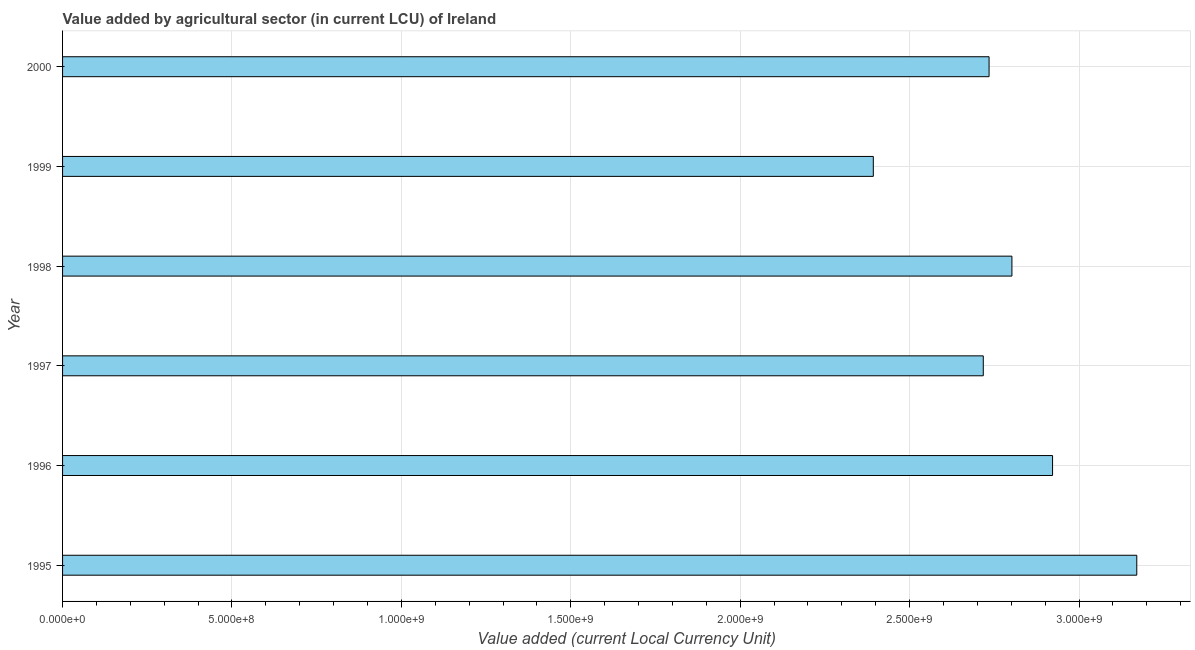Does the graph contain grids?
Make the answer very short. Yes. What is the title of the graph?
Your answer should be very brief. Value added by agricultural sector (in current LCU) of Ireland. What is the label or title of the X-axis?
Provide a succinct answer. Value added (current Local Currency Unit). What is the value added by agriculture sector in 1997?
Provide a succinct answer. 2.72e+09. Across all years, what is the maximum value added by agriculture sector?
Offer a very short reply. 3.17e+09. Across all years, what is the minimum value added by agriculture sector?
Keep it short and to the point. 2.39e+09. What is the sum of the value added by agriculture sector?
Offer a terse response. 1.67e+1. What is the difference between the value added by agriculture sector in 1997 and 2000?
Ensure brevity in your answer.  -1.71e+07. What is the average value added by agriculture sector per year?
Your response must be concise. 2.79e+09. What is the median value added by agriculture sector?
Provide a short and direct response. 2.77e+09. What is the ratio of the value added by agriculture sector in 1995 to that in 1998?
Provide a succinct answer. 1.13. Is the difference between the value added by agriculture sector in 1995 and 1999 greater than the difference between any two years?
Give a very brief answer. Yes. What is the difference between the highest and the second highest value added by agriculture sector?
Give a very brief answer. 2.49e+08. Is the sum of the value added by agriculture sector in 1997 and 1999 greater than the maximum value added by agriculture sector across all years?
Offer a very short reply. Yes. What is the difference between the highest and the lowest value added by agriculture sector?
Offer a very short reply. 7.78e+08. How many bars are there?
Offer a very short reply. 6. How many years are there in the graph?
Your answer should be very brief. 6. What is the difference between two consecutive major ticks on the X-axis?
Give a very brief answer. 5.00e+08. Are the values on the major ticks of X-axis written in scientific E-notation?
Keep it short and to the point. Yes. What is the Value added (current Local Currency Unit) of 1995?
Your answer should be very brief. 3.17e+09. What is the Value added (current Local Currency Unit) of 1996?
Offer a terse response. 2.92e+09. What is the Value added (current Local Currency Unit) of 1997?
Your response must be concise. 2.72e+09. What is the Value added (current Local Currency Unit) of 1998?
Offer a very short reply. 2.80e+09. What is the Value added (current Local Currency Unit) in 1999?
Provide a succinct answer. 2.39e+09. What is the Value added (current Local Currency Unit) of 2000?
Offer a very short reply. 2.73e+09. What is the difference between the Value added (current Local Currency Unit) in 1995 and 1996?
Your answer should be compact. 2.49e+08. What is the difference between the Value added (current Local Currency Unit) in 1995 and 1997?
Ensure brevity in your answer.  4.53e+08. What is the difference between the Value added (current Local Currency Unit) in 1995 and 1998?
Give a very brief answer. 3.68e+08. What is the difference between the Value added (current Local Currency Unit) in 1995 and 1999?
Offer a very short reply. 7.78e+08. What is the difference between the Value added (current Local Currency Unit) in 1995 and 2000?
Ensure brevity in your answer.  4.36e+08. What is the difference between the Value added (current Local Currency Unit) in 1996 and 1997?
Offer a very short reply. 2.04e+08. What is the difference between the Value added (current Local Currency Unit) in 1996 and 1998?
Ensure brevity in your answer.  1.20e+08. What is the difference between the Value added (current Local Currency Unit) in 1996 and 1999?
Your answer should be compact. 5.29e+08. What is the difference between the Value added (current Local Currency Unit) in 1996 and 2000?
Provide a short and direct response. 1.87e+08. What is the difference between the Value added (current Local Currency Unit) in 1997 and 1998?
Ensure brevity in your answer.  -8.45e+07. What is the difference between the Value added (current Local Currency Unit) in 1997 and 1999?
Your response must be concise. 3.25e+08. What is the difference between the Value added (current Local Currency Unit) in 1997 and 2000?
Your response must be concise. -1.71e+07. What is the difference between the Value added (current Local Currency Unit) in 1998 and 1999?
Offer a terse response. 4.09e+08. What is the difference between the Value added (current Local Currency Unit) in 1998 and 2000?
Offer a very short reply. 6.74e+07. What is the difference between the Value added (current Local Currency Unit) in 1999 and 2000?
Make the answer very short. -3.42e+08. What is the ratio of the Value added (current Local Currency Unit) in 1995 to that in 1996?
Your answer should be compact. 1.08. What is the ratio of the Value added (current Local Currency Unit) in 1995 to that in 1997?
Ensure brevity in your answer.  1.17. What is the ratio of the Value added (current Local Currency Unit) in 1995 to that in 1998?
Provide a succinct answer. 1.13. What is the ratio of the Value added (current Local Currency Unit) in 1995 to that in 1999?
Give a very brief answer. 1.32. What is the ratio of the Value added (current Local Currency Unit) in 1995 to that in 2000?
Your answer should be very brief. 1.16. What is the ratio of the Value added (current Local Currency Unit) in 1996 to that in 1997?
Ensure brevity in your answer.  1.07. What is the ratio of the Value added (current Local Currency Unit) in 1996 to that in 1998?
Your response must be concise. 1.04. What is the ratio of the Value added (current Local Currency Unit) in 1996 to that in 1999?
Offer a terse response. 1.22. What is the ratio of the Value added (current Local Currency Unit) in 1996 to that in 2000?
Ensure brevity in your answer.  1.07. What is the ratio of the Value added (current Local Currency Unit) in 1997 to that in 1998?
Your answer should be very brief. 0.97. What is the ratio of the Value added (current Local Currency Unit) in 1997 to that in 1999?
Provide a short and direct response. 1.14. What is the ratio of the Value added (current Local Currency Unit) in 1998 to that in 1999?
Give a very brief answer. 1.17. 